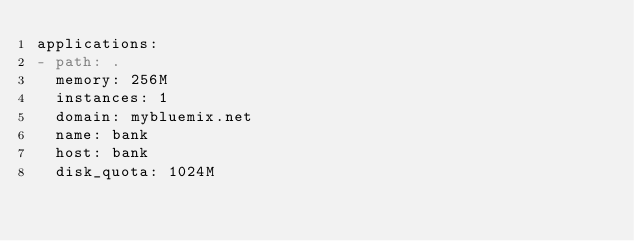Convert code to text. <code><loc_0><loc_0><loc_500><loc_500><_YAML_>applications:
- path: .
  memory: 256M
  instances: 1
  domain: mybluemix.net
  name: bank
  host: bank 
  disk_quota: 1024M
</code> 